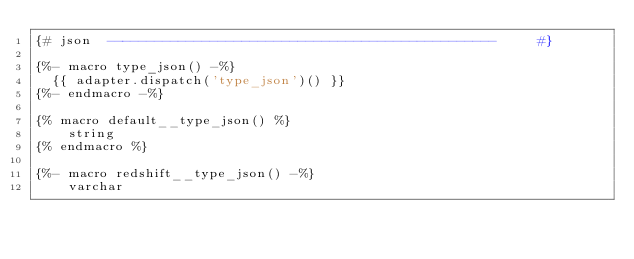<code> <loc_0><loc_0><loc_500><loc_500><_SQL_>{# json  -------------------------------------------------     #}

{%- macro type_json() -%}
  {{ adapter.dispatch('type_json')() }}
{%- endmacro -%}

{% macro default__type_json() %}
    string
{% endmacro %}

{%- macro redshift__type_json() -%}
    varchar</code> 